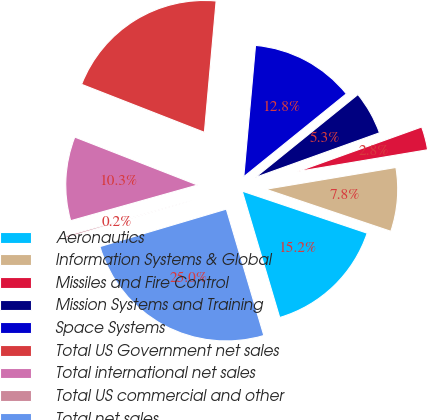<chart> <loc_0><loc_0><loc_500><loc_500><pie_chart><fcel>Aeronautics<fcel>Information Systems & Global<fcel>Missiles and Fire Control<fcel>Mission Systems and Training<fcel>Space Systems<fcel>Total US Government net sales<fcel>Total international net sales<fcel>Total US commercial and other<fcel>Total net sales<nl><fcel>15.24%<fcel>7.81%<fcel>2.85%<fcel>5.33%<fcel>12.76%<fcel>20.49%<fcel>10.29%<fcel>0.23%<fcel>25.0%<nl></chart> 